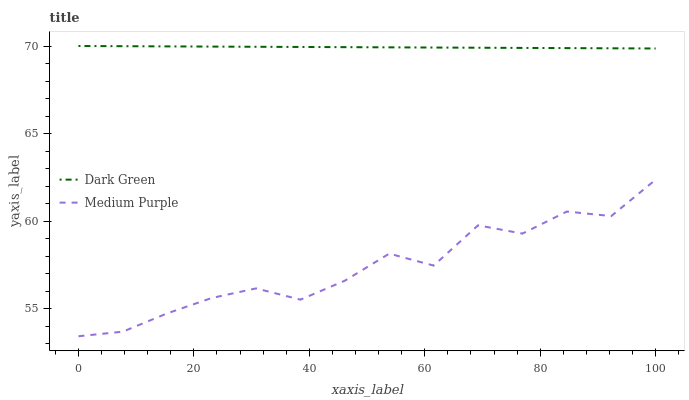Does Medium Purple have the minimum area under the curve?
Answer yes or no. Yes. Does Dark Green have the maximum area under the curve?
Answer yes or no. Yes. Does Dark Green have the minimum area under the curve?
Answer yes or no. No. Is Dark Green the smoothest?
Answer yes or no. Yes. Is Medium Purple the roughest?
Answer yes or no. Yes. Is Dark Green the roughest?
Answer yes or no. No. Does Medium Purple have the lowest value?
Answer yes or no. Yes. Does Dark Green have the lowest value?
Answer yes or no. No. Does Dark Green have the highest value?
Answer yes or no. Yes. Is Medium Purple less than Dark Green?
Answer yes or no. Yes. Is Dark Green greater than Medium Purple?
Answer yes or no. Yes. Does Medium Purple intersect Dark Green?
Answer yes or no. No. 